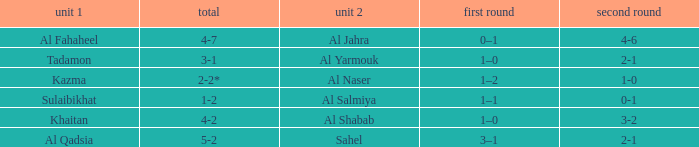What is the 1st leg of the Al Fahaheel Team 1? 0–1. 